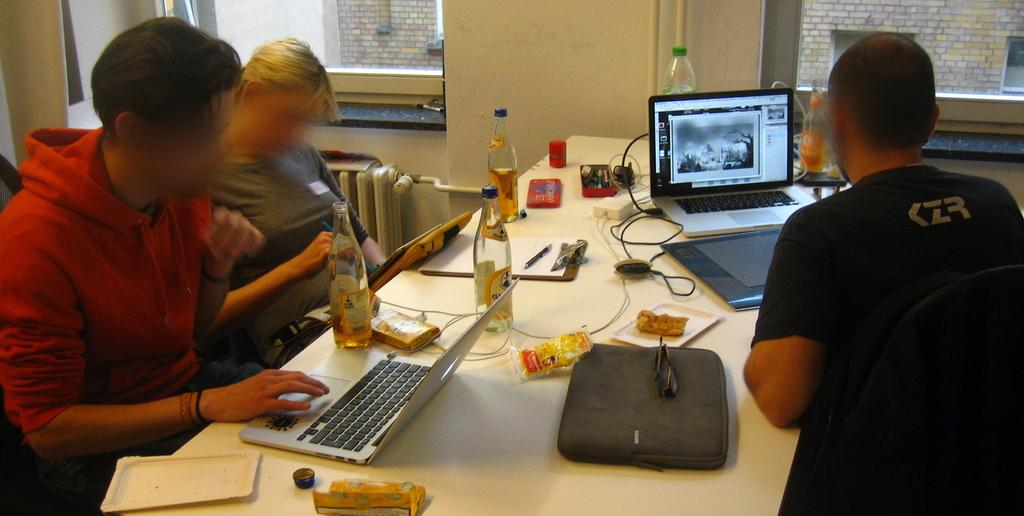<image>
Write a terse but informative summary of the picture. Man in a black shirt that says "CZR" using a laptop. 